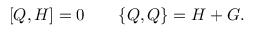Convert formula to latex. <formula><loc_0><loc_0><loc_500><loc_500>[ Q , H ] = 0 \quad \{ Q , Q \} = H + G .</formula> 